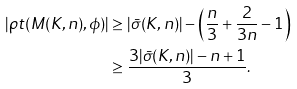Convert formula to latex. <formula><loc_0><loc_0><loc_500><loc_500>| \rho t ( M ( K , n ) , \phi ) | & \geq | \bar { \sigma } ( K , n ) | - \left ( \frac { n } { 3 } + \frac { 2 } { 3 n } - 1 \right ) \\ & \geq \frac { 3 | \bar { \sigma } ( K , n ) | - n + 1 } { 3 } .</formula> 